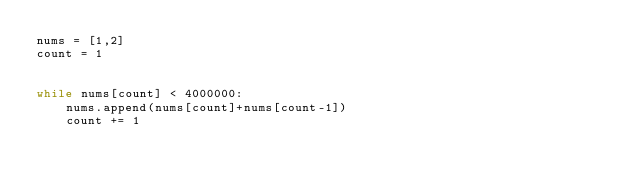<code> <loc_0><loc_0><loc_500><loc_500><_Python_>nums = [1,2]
count = 1


while nums[count] < 4000000:
    nums.append(nums[count]+nums[count-1])
    count += 1</code> 